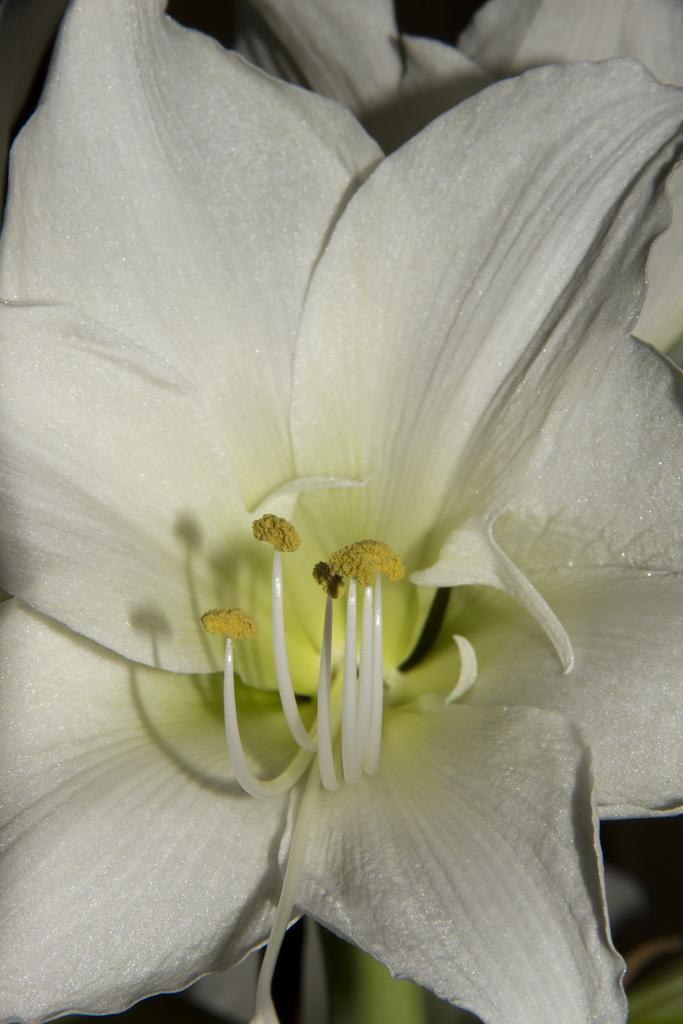What is the main subject of the image? There is a flower in the image. Can you describe the background of the image? The background of the image is blurry. What type of pancake is being served during the week in the image? There is no pancake or reference to a week present in the image; it features a flower with a blurry background. 